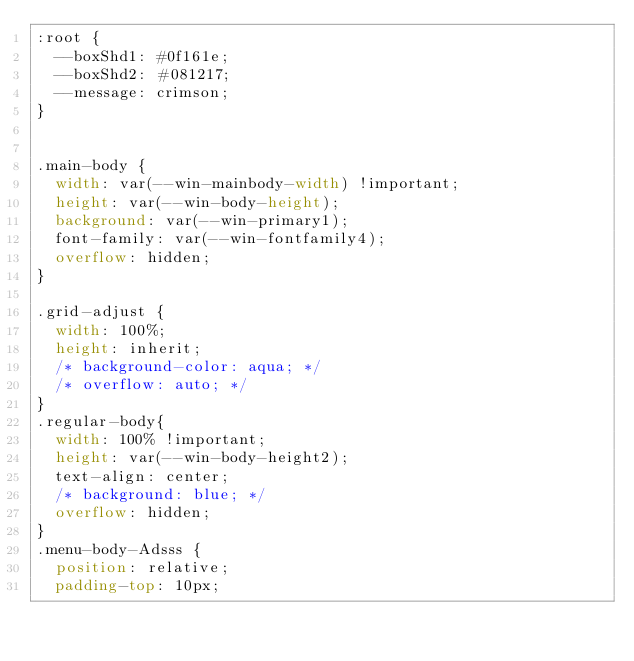<code> <loc_0><loc_0><loc_500><loc_500><_CSS_>:root {
  --boxShd1: #0f161e;
  --boxShd2: #081217;
  --message: crimson;
}


.main-body {
  width: var(--win-mainbody-width) !important;
  height: var(--win-body-height);
  background: var(--win-primary1);
  font-family: var(--win-fontfamily4);
  overflow: hidden;
}

.grid-adjust {
  width: 100%;
  height: inherit;
  /* background-color: aqua; */
  /* overflow: auto; */
}
.regular-body{
  width: 100% !important;
  height: var(--win-body-height2);
  text-align: center;
  /* background: blue; */
  overflow: hidden;
}
.menu-body-Adsss {
  position: relative;
  padding-top: 10px;</code> 